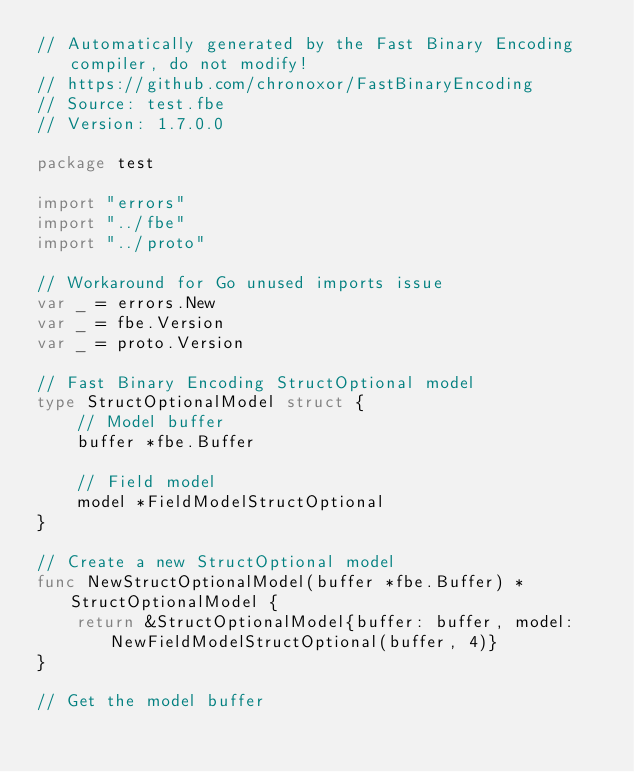<code> <loc_0><loc_0><loc_500><loc_500><_Go_>// Automatically generated by the Fast Binary Encoding compiler, do not modify!
// https://github.com/chronoxor/FastBinaryEncoding
// Source: test.fbe
// Version: 1.7.0.0

package test

import "errors"
import "../fbe"
import "../proto"

// Workaround for Go unused imports issue
var _ = errors.New
var _ = fbe.Version
var _ = proto.Version

// Fast Binary Encoding StructOptional model
type StructOptionalModel struct {
    // Model buffer
    buffer *fbe.Buffer

    // Field model
    model *FieldModelStructOptional
}

// Create a new StructOptional model
func NewStructOptionalModel(buffer *fbe.Buffer) *StructOptionalModel {
    return &StructOptionalModel{buffer: buffer, model: NewFieldModelStructOptional(buffer, 4)}
}

// Get the model buffer</code> 